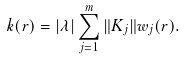<formula> <loc_0><loc_0><loc_500><loc_500>k ( r ) = | \lambda | \sum _ { j = 1 } ^ { m } \| K _ { j } \| w _ { j } ( r ) .</formula> 